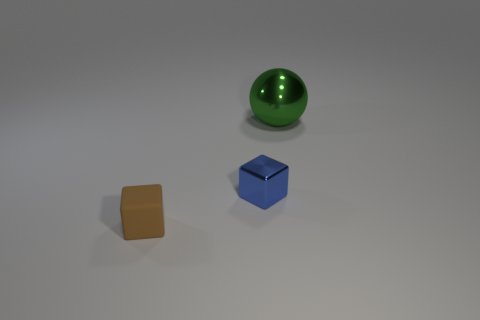Add 2 big green shiny things. How many objects exist? 5 Subtract all brown cubes. How many cubes are left? 1 Subtract all red blocks. Subtract all cyan cylinders. How many blocks are left? 2 Subtract all purple cylinders. How many brown cubes are left? 1 Subtract all tiny purple rubber objects. Subtract all small matte blocks. How many objects are left? 2 Add 1 blue metallic things. How many blue metallic things are left? 2 Add 2 red matte cylinders. How many red matte cylinders exist? 2 Subtract 1 brown blocks. How many objects are left? 2 Subtract all blocks. How many objects are left? 1 